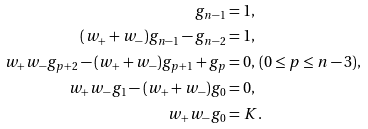<formula> <loc_0><loc_0><loc_500><loc_500>g _ { n - 1 } & = 1 , \\ ( w _ { + } + w _ { - } ) g _ { n - 1 } - g _ { n - 2 } & = 1 , \\ w _ { + } w _ { - } g _ { p + 2 } - ( w _ { + } + w _ { - } ) g _ { p + 1 } + g _ { p } & = 0 , \, ( 0 \leq p \leq n - 3 ) , \\ w _ { + } w _ { - } g _ { 1 } - ( w _ { + } + w _ { - } ) g _ { 0 } & = 0 , \\ w _ { + } w _ { - } g _ { 0 } & = K .</formula> 